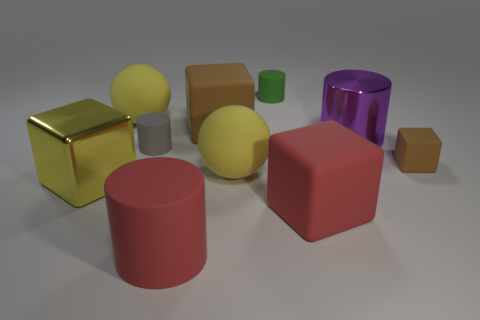What textures are apparent in the objects shown? Most objects exhibit a matte texture, which diffuses light and minimizes reflections, while the gold cube has a distinct reflective texture creating a mirror-like appearance. How does the lighting affect the appearance of the objects? The lighting appears to be soft and diffused, casting gentle shadows and highlighting the texture of the objects. It enhances the reflective property of the gold cube while softly illuminating the matte surfaces. 